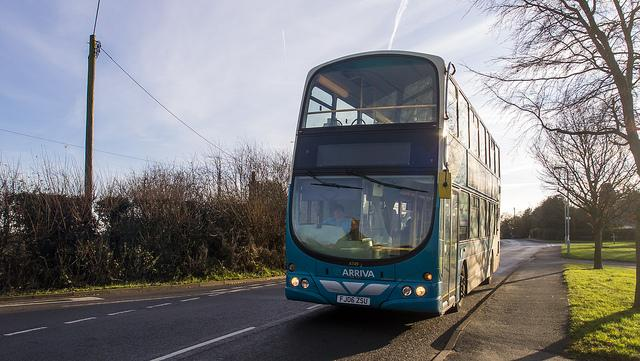How is this bus different from traditional US buses? double decker 